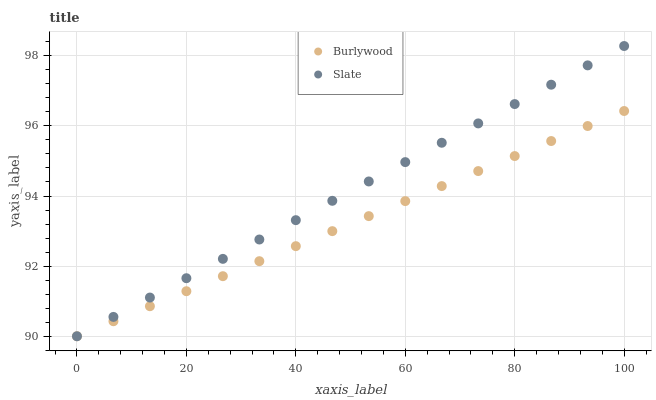Does Burlywood have the minimum area under the curve?
Answer yes or no. Yes. Does Slate have the maximum area under the curve?
Answer yes or no. Yes. Does Slate have the minimum area under the curve?
Answer yes or no. No. Is Slate the smoothest?
Answer yes or no. Yes. Is Burlywood the roughest?
Answer yes or no. Yes. Is Slate the roughest?
Answer yes or no. No. Does Burlywood have the lowest value?
Answer yes or no. Yes. Does Slate have the highest value?
Answer yes or no. Yes. Does Slate intersect Burlywood?
Answer yes or no. Yes. Is Slate less than Burlywood?
Answer yes or no. No. Is Slate greater than Burlywood?
Answer yes or no. No. 